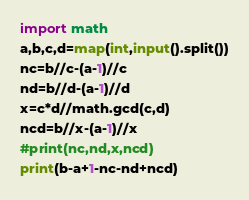<code> <loc_0><loc_0><loc_500><loc_500><_Python_>import math
a,b,c,d=map(int,input().split())
nc=b//c-(a-1)//c
nd=b//d-(a-1)//d
x=c*d//math.gcd(c,d)
ncd=b//x-(a-1)//x
#print(nc,nd,x,ncd)
print(b-a+1-nc-nd+ncd)
</code> 